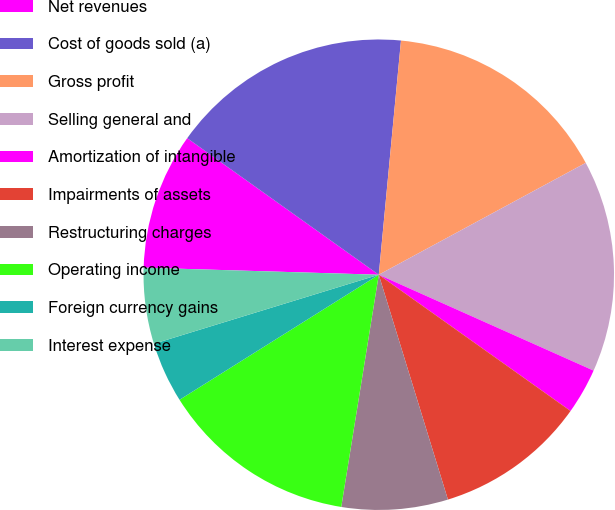Convert chart. <chart><loc_0><loc_0><loc_500><loc_500><pie_chart><fcel>Net revenues<fcel>Cost of goods sold (a)<fcel>Gross profit<fcel>Selling general and<fcel>Amortization of intangible<fcel>Impairments of assets<fcel>Restructuring charges<fcel>Operating income<fcel>Foreign currency gains<fcel>Interest expense<nl><fcel>9.38%<fcel>16.65%<fcel>15.61%<fcel>14.57%<fcel>3.15%<fcel>10.42%<fcel>7.3%<fcel>13.53%<fcel>4.18%<fcel>5.22%<nl></chart> 